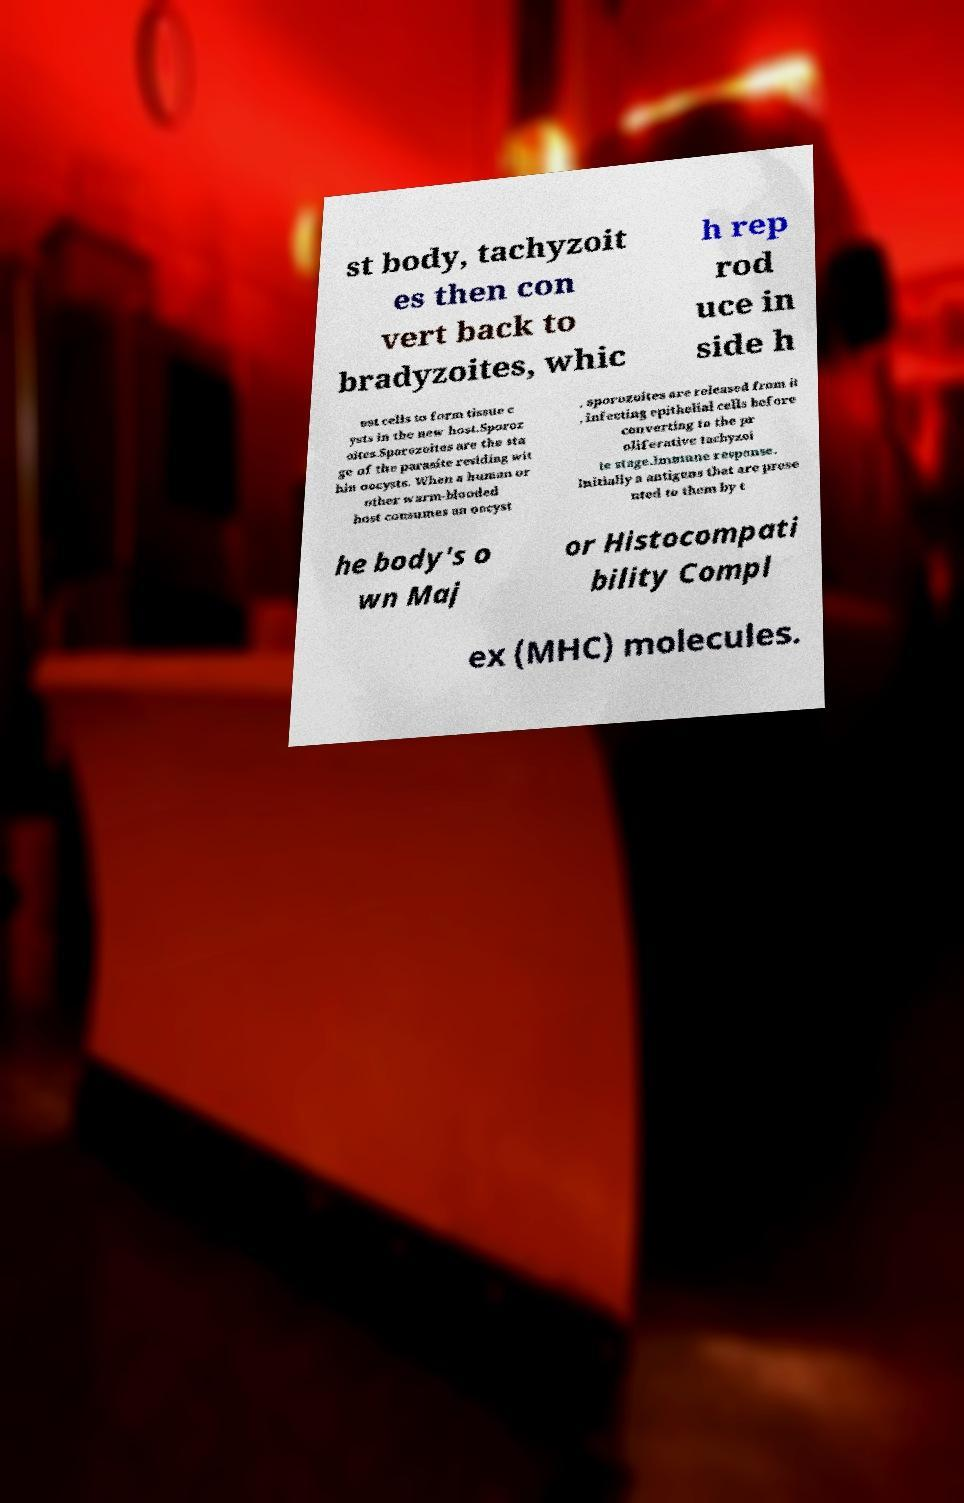I need the written content from this picture converted into text. Can you do that? st body, tachyzoit es then con vert back to bradyzoites, whic h rep rod uce in side h ost cells to form tissue c ysts in the new host.Sporoz oites.Sporozoites are the sta ge of the parasite residing wit hin oocysts. When a human or other warm-blooded host consumes an oocyst , sporozoites are released from it , infecting epithelial cells before converting to the pr oliferative tachyzoi te stage.Immune response. Initially a antigens that are prese nted to them by t he body's o wn Maj or Histocompati bility Compl ex (MHC) molecules. 